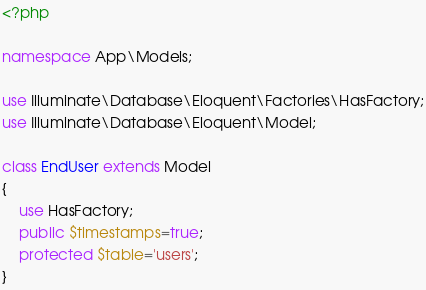Convert code to text. <code><loc_0><loc_0><loc_500><loc_500><_PHP_><?php

namespace App\Models;

use Illuminate\Database\Eloquent\Factories\HasFactory;
use Illuminate\Database\Eloquent\Model;

class EndUser extends Model
{
    use HasFactory;
    public $timestamps=true;
    protected $table='users';
}
</code> 